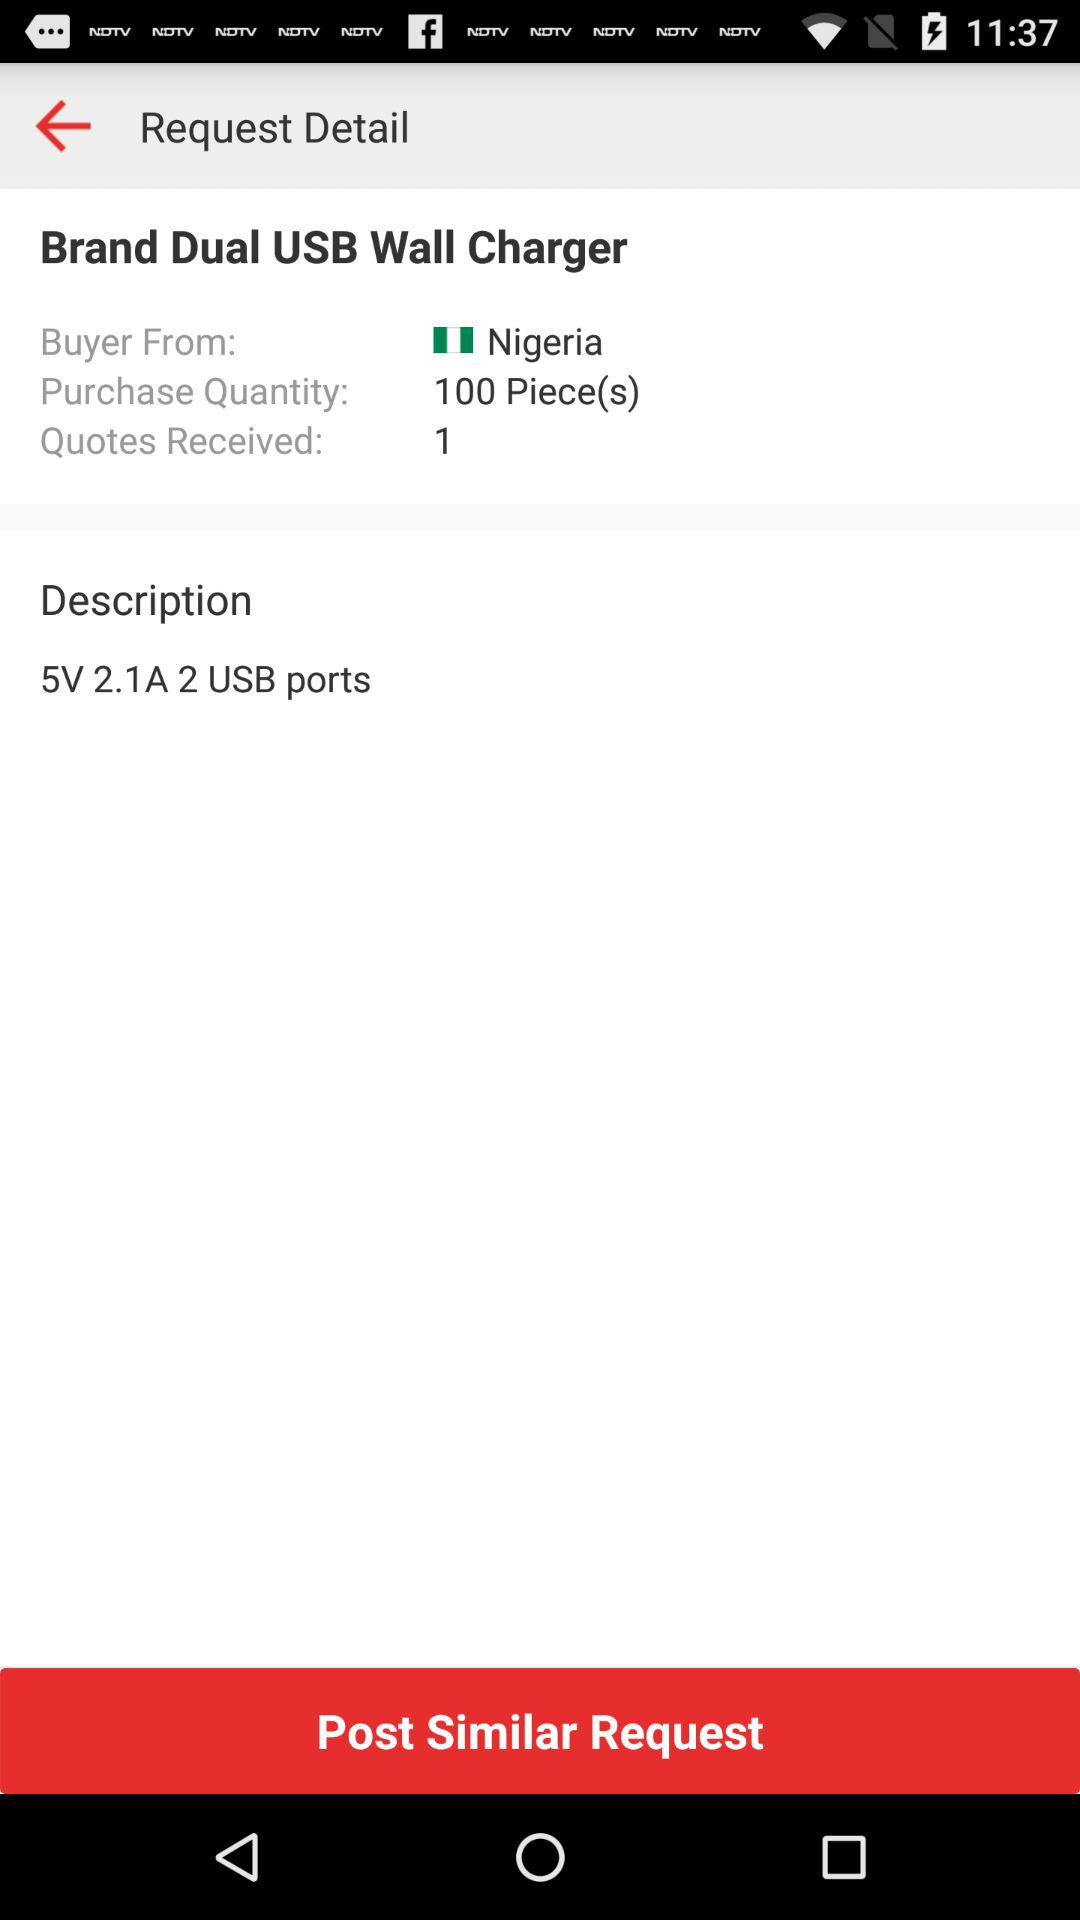What is the purchase quantity? The purchase quantity is 100 pieces. 